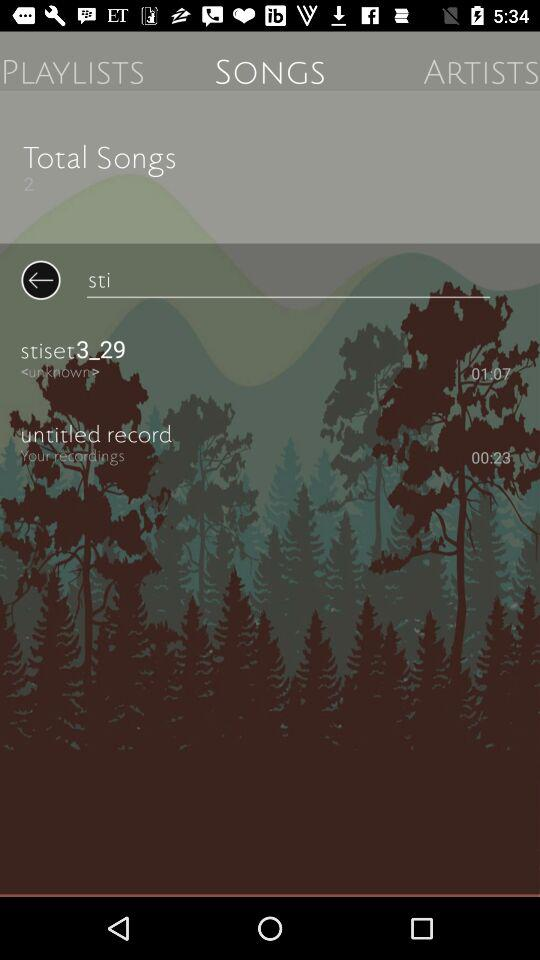How many songs are there in total? The total songs are 2. 